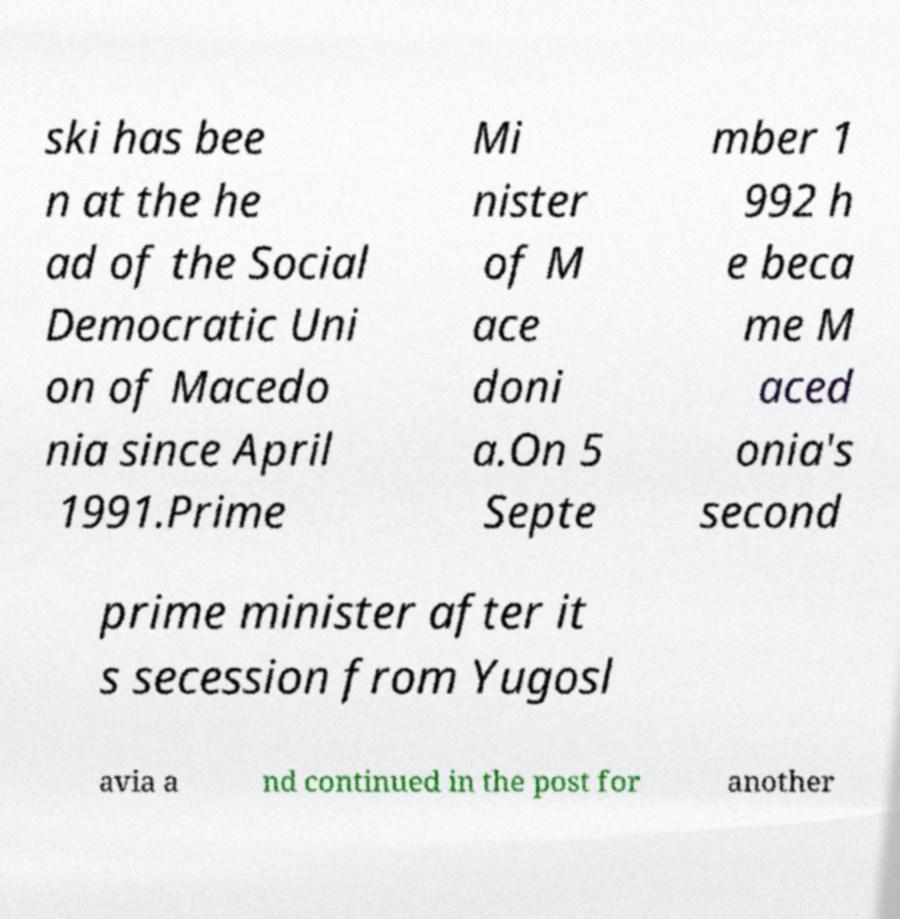Please read and relay the text visible in this image. What does it say? ski has bee n at the he ad of the Social Democratic Uni on of Macedo nia since April 1991.Prime Mi nister of M ace doni a.On 5 Septe mber 1 992 h e beca me M aced onia's second prime minister after it s secession from Yugosl avia a nd continued in the post for another 